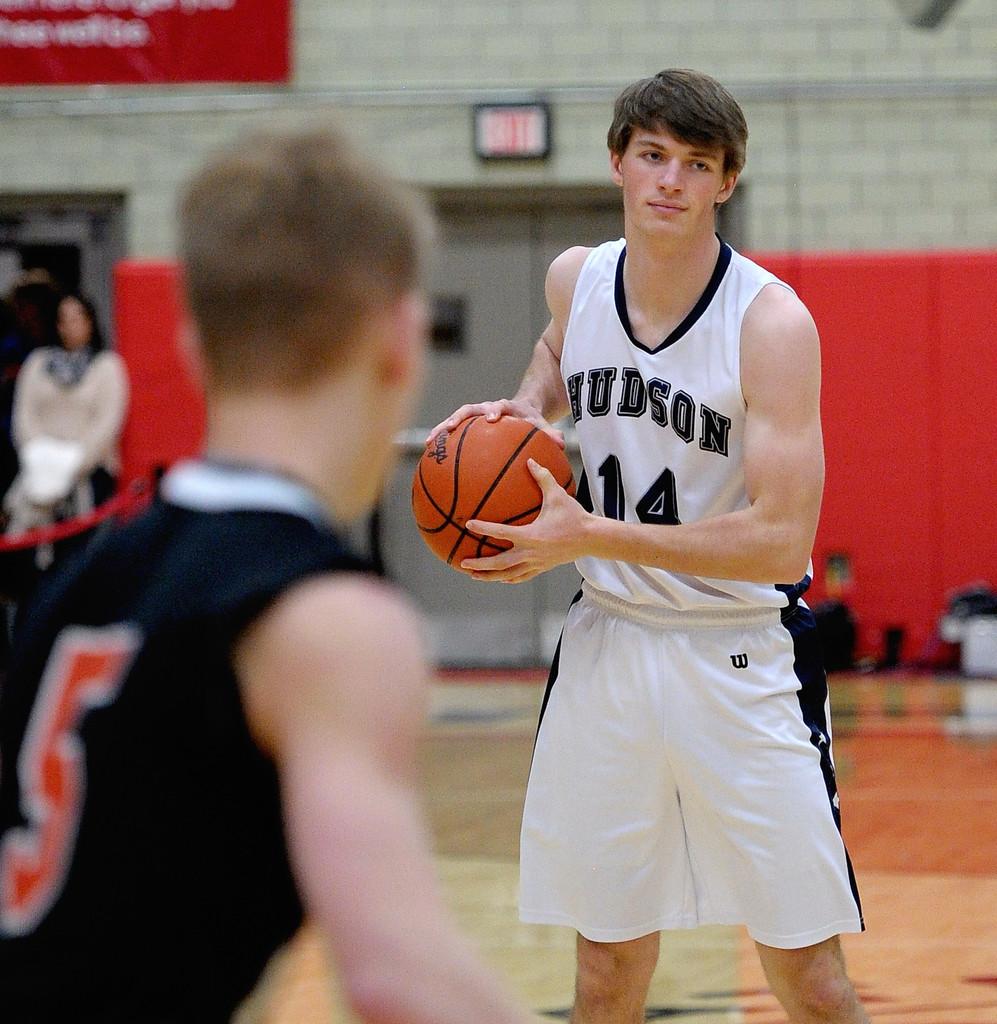What jersey number does the defender wear?
Provide a succinct answer. 5. What letter on the jersey indicates the brand that makes the jersey?
Your response must be concise. W. 